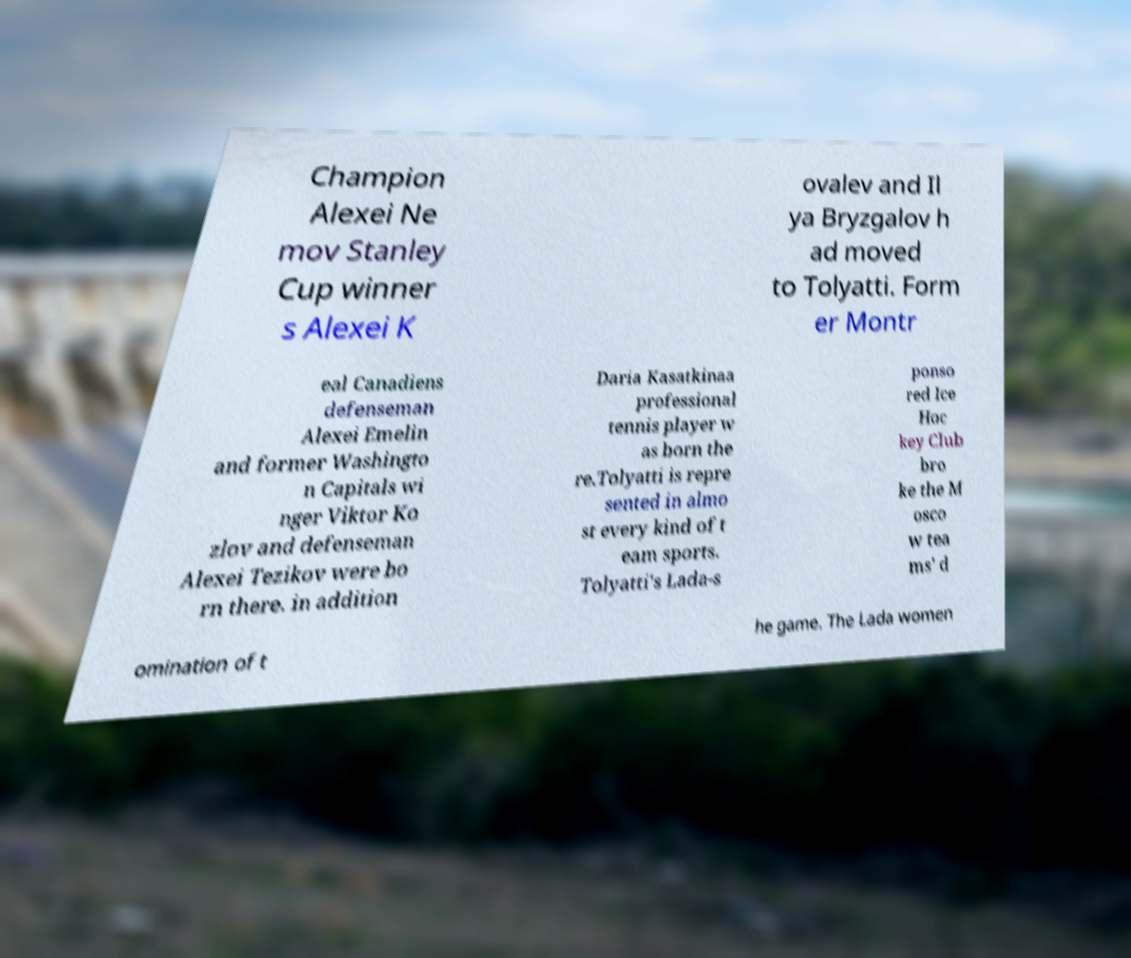Can you accurately transcribe the text from the provided image for me? Champion Alexei Ne mov Stanley Cup winner s Alexei K ovalev and Il ya Bryzgalov h ad moved to Tolyatti. Form er Montr eal Canadiens defenseman Alexei Emelin and former Washingto n Capitals wi nger Viktor Ko zlov and defenseman Alexei Tezikov were bo rn there. in addition Daria Kasatkinaa professional tennis player w as born the re.Tolyatti is repre sented in almo st every kind of t eam sports. Tolyatti's Lada-s ponso red Ice Hoc key Club bro ke the M osco w tea ms' d omination of t he game. The Lada women 